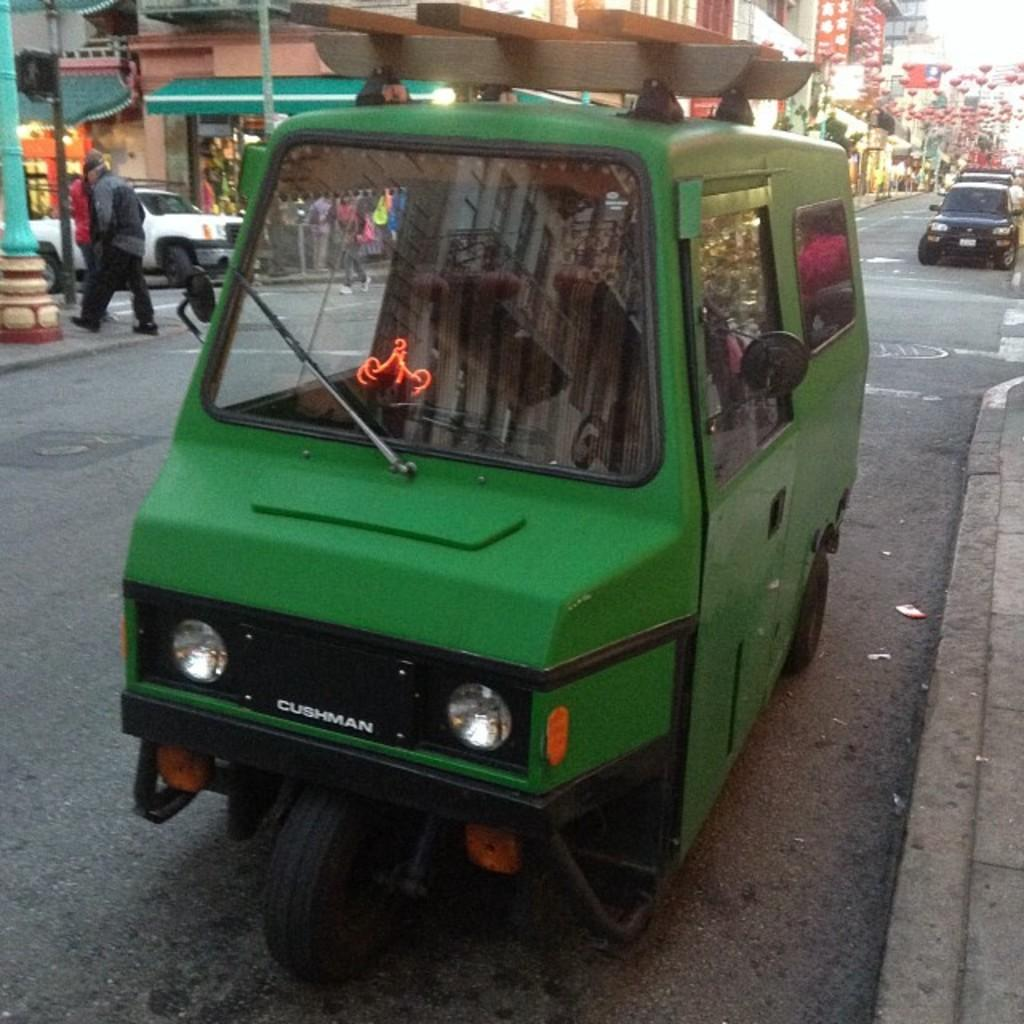What color is the vehicle in the image? The vehicle in the image is green. Where is the vehicle located in the image? The vehicle is parked on the road. What can be seen in the background of the image? There are many buildings and poles in the background of the image. Are there any other vehicles visible in the image? Yes, there are vehicles in the background of the image. How many people can be seen in the image? Few people are visible in the image. What type of clover is growing on the stem in the image? There is no clover or stem present in the image. How does the war affect the people in the image? There is no indication of a war or any conflict in the image. 